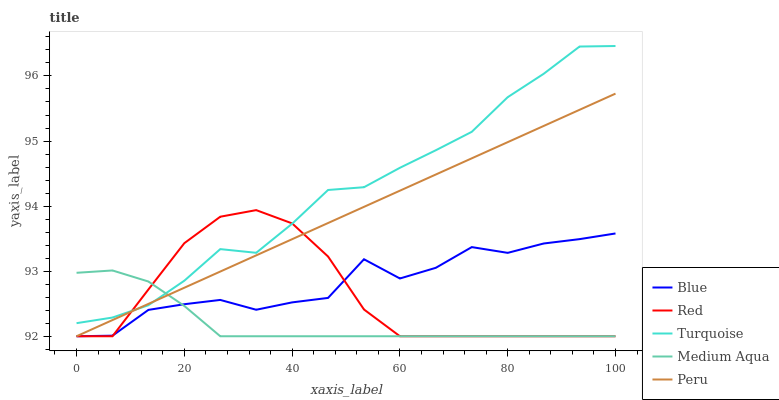Does Medium Aqua have the minimum area under the curve?
Answer yes or no. Yes. Does Turquoise have the maximum area under the curve?
Answer yes or no. Yes. Does Turquoise have the minimum area under the curve?
Answer yes or no. No. Does Medium Aqua have the maximum area under the curve?
Answer yes or no. No. Is Peru the smoothest?
Answer yes or no. Yes. Is Blue the roughest?
Answer yes or no. Yes. Is Turquoise the smoothest?
Answer yes or no. No. Is Turquoise the roughest?
Answer yes or no. No. Does Turquoise have the lowest value?
Answer yes or no. No. Does Medium Aqua have the highest value?
Answer yes or no. No. Is Blue less than Turquoise?
Answer yes or no. Yes. Is Turquoise greater than Blue?
Answer yes or no. Yes. Does Blue intersect Turquoise?
Answer yes or no. No. 